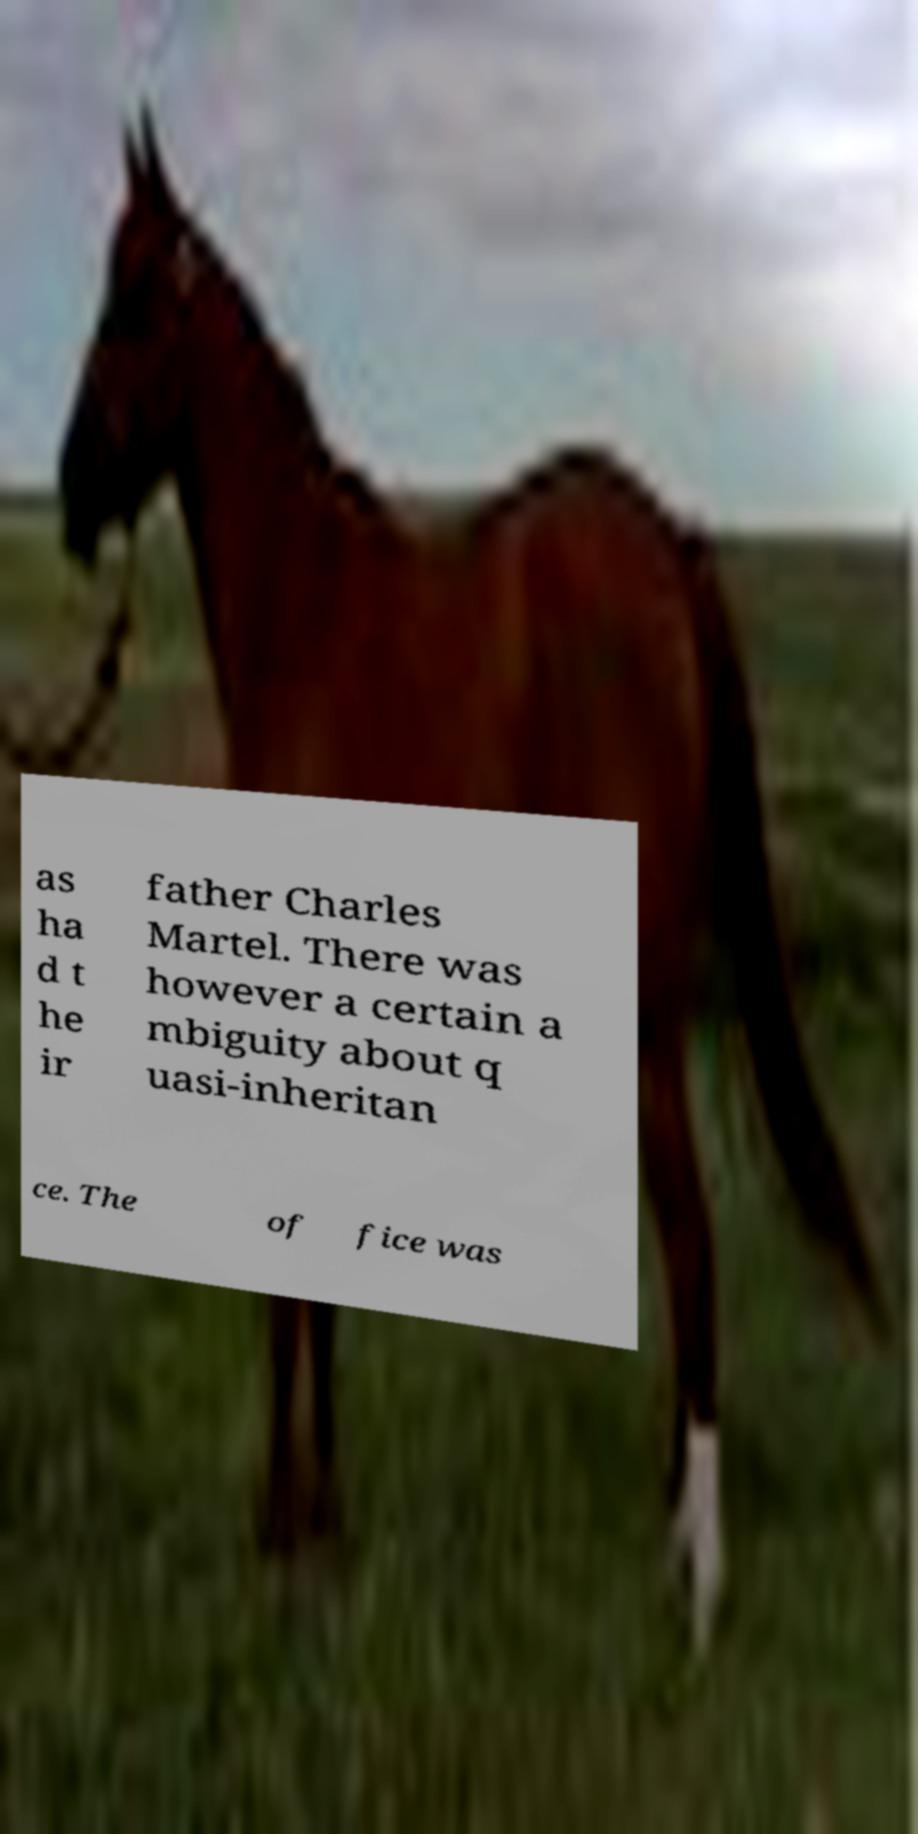Please identify and transcribe the text found in this image. as ha d t he ir father Charles Martel. There was however a certain a mbiguity about q uasi-inheritan ce. The of fice was 